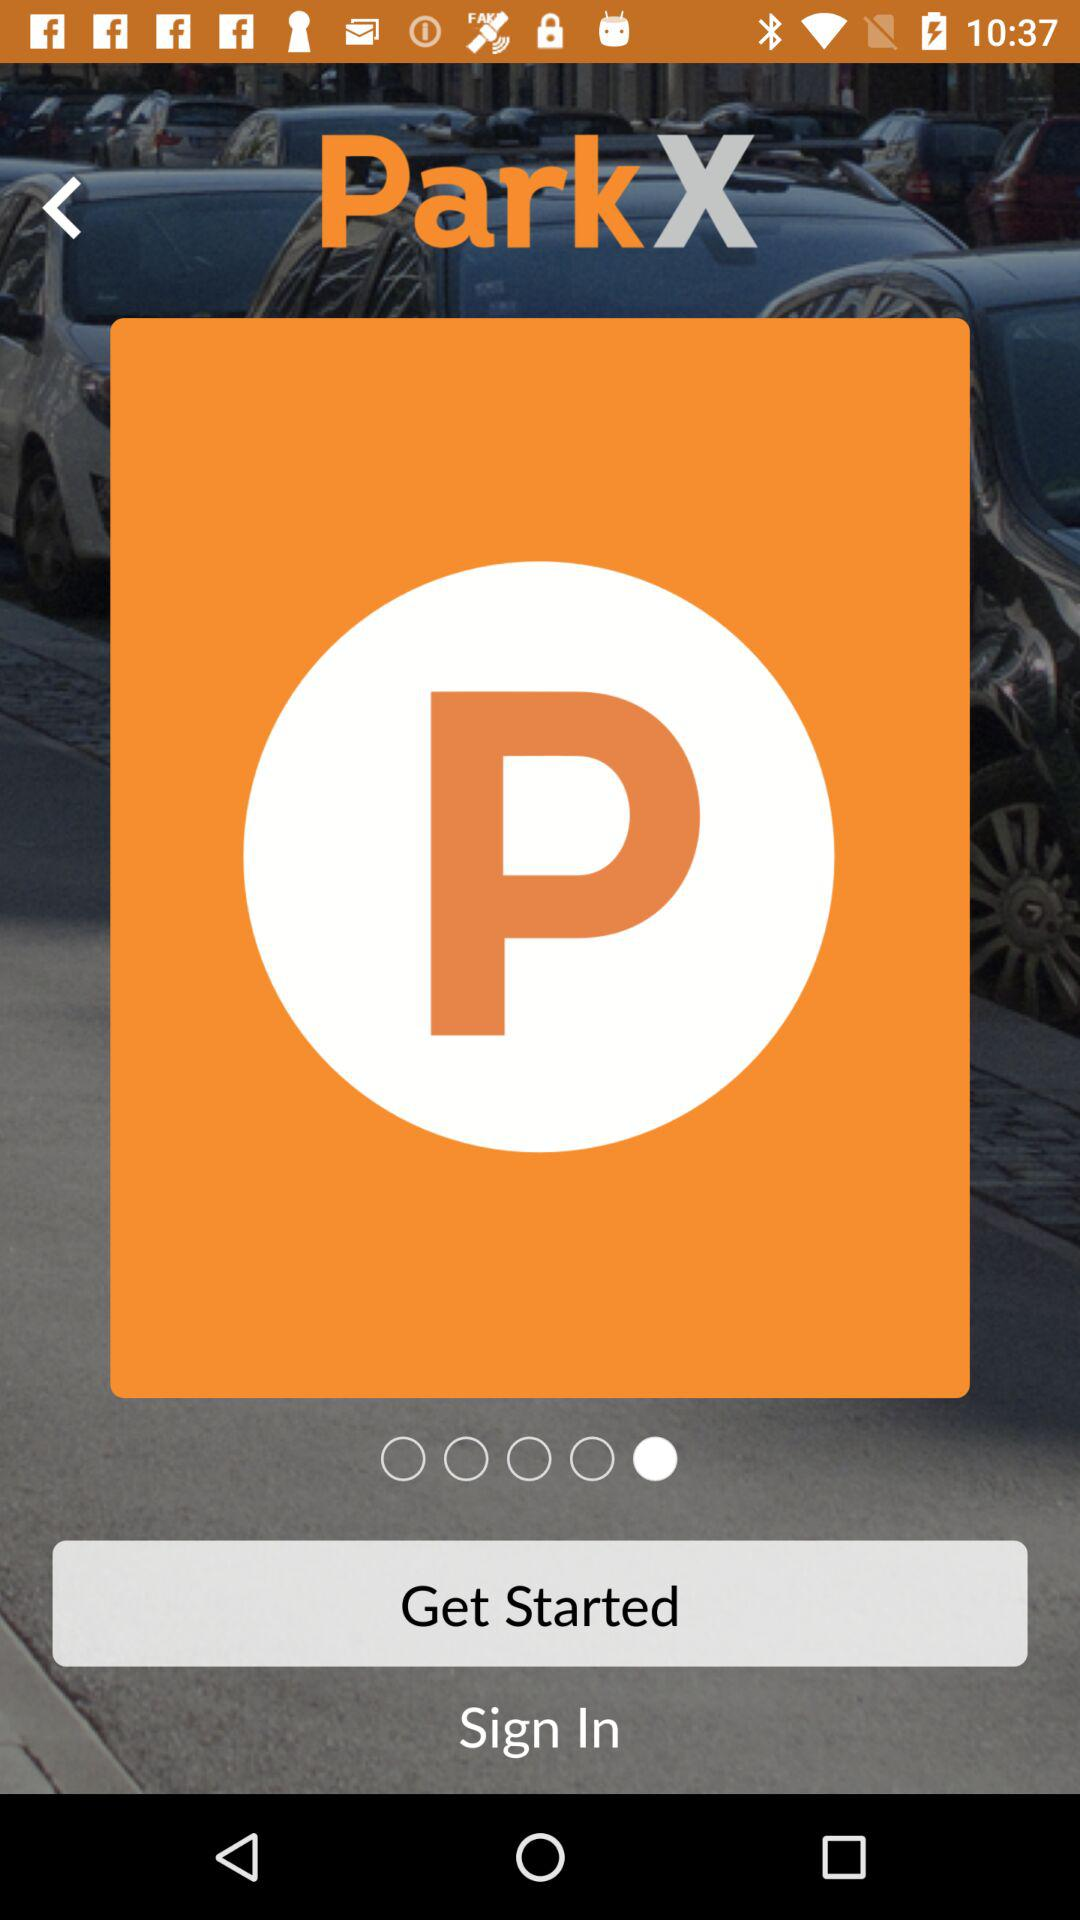What is the name of the application? The name of the application is "ParkX". 